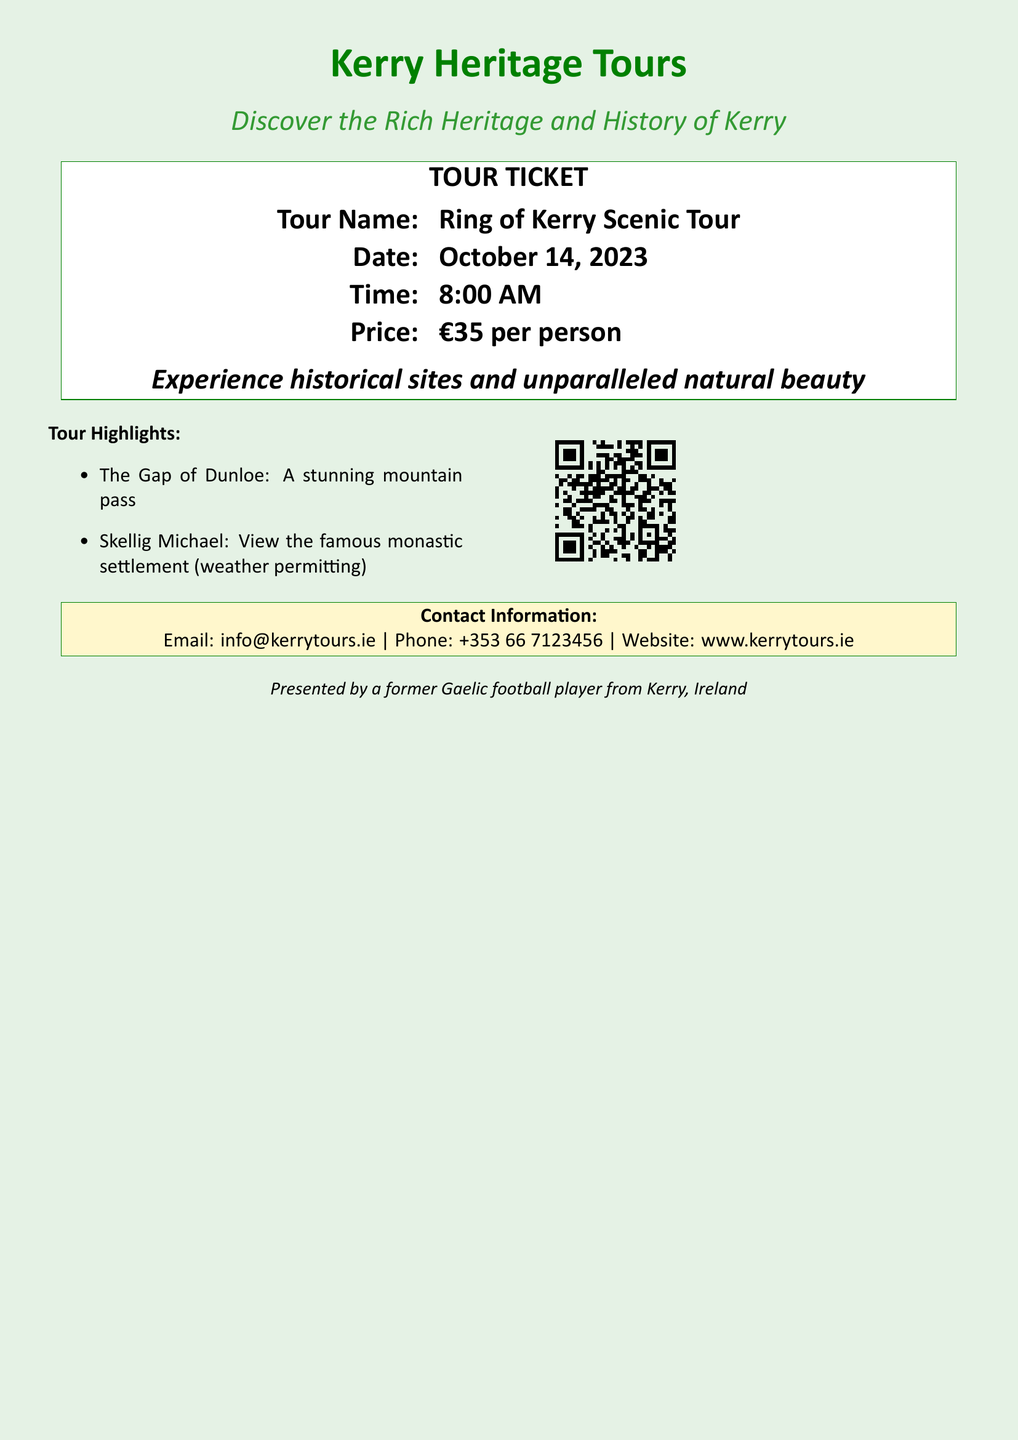What is the name of the tour? The name of the tour is explicitly mentioned in the document.
Answer: Ring of Kerry Scenic Tour What is the date of the tour? The document specifies the date in the ticket information section.
Answer: October 14, 2023 What time does the tour start? The starting time is clearly indicated in the document's schedule.
Answer: 8:00 AM What is the price per person for the tour? The document provides the pricing information under the ticket details.
Answer: €35 per person What prominent site can you view during the tour? The document mentions a specific historical site in the tour highlights.
Answer: Skellig Michael What natural feature will you experience on the tour? The highlights section of the document lists a feature related to nature.
Answer: The Gap of Dunloe How can you contact the tour provider? Contact information is provided in the document for inquiries.
Answer: info@kerrytours.ie What type of person presented the tour? The conclusion of the document mentions a specific background related to the presenter.
Answer: A former Gaelic football player from Kerry, Ireland 